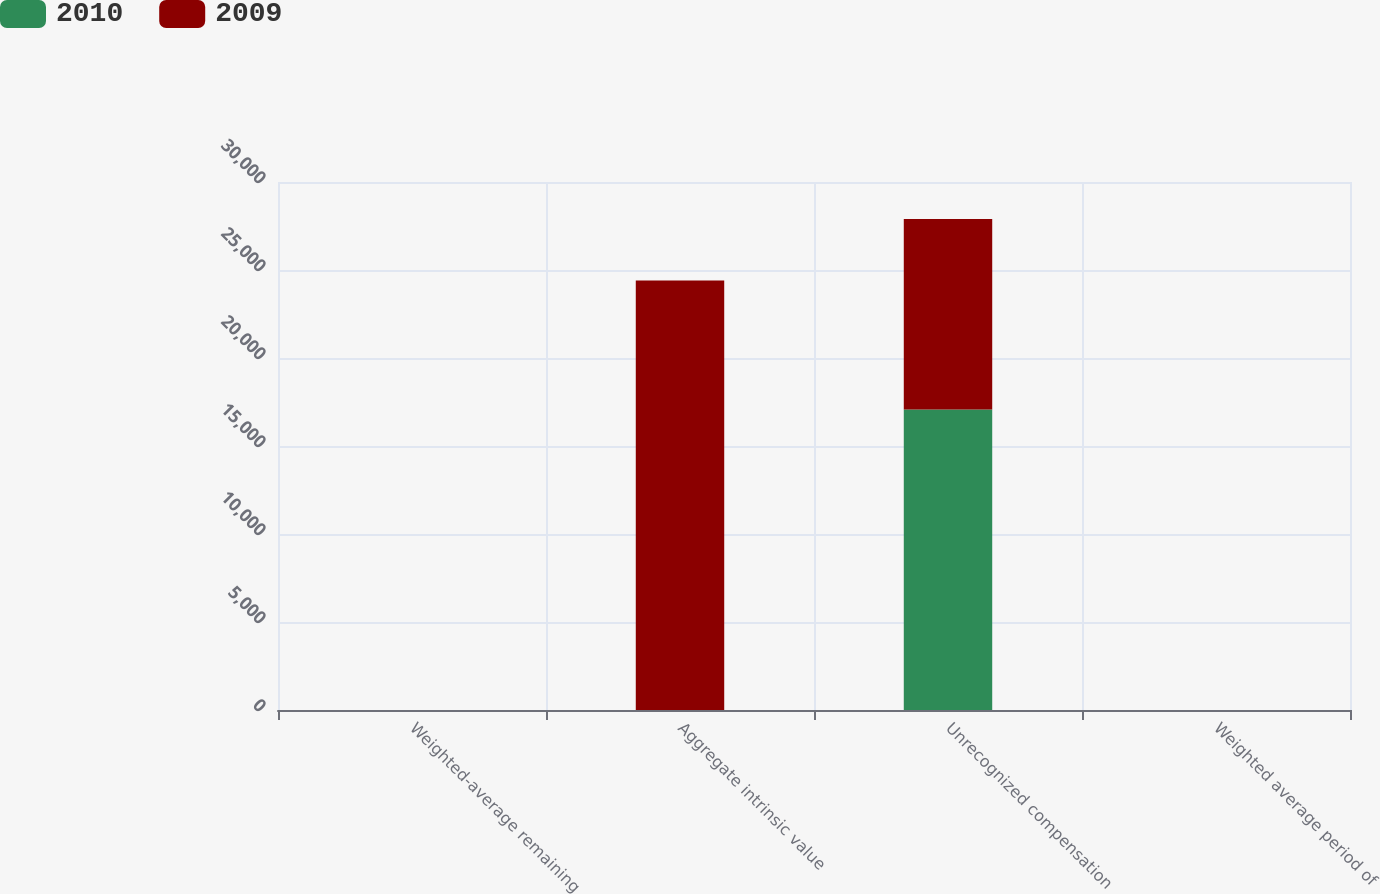Convert chart to OTSL. <chart><loc_0><loc_0><loc_500><loc_500><stacked_bar_chart><ecel><fcel>Weighted-average remaining<fcel>Aggregate intrinsic value<fcel>Unrecognized compensation<fcel>Weighted average period of<nl><fcel>2010<fcel>2.85<fcel>3.33<fcel>17077<fcel>1.33<nl><fcel>2009<fcel>3.33<fcel>24407<fcel>10822<fcel>1.72<nl></chart> 